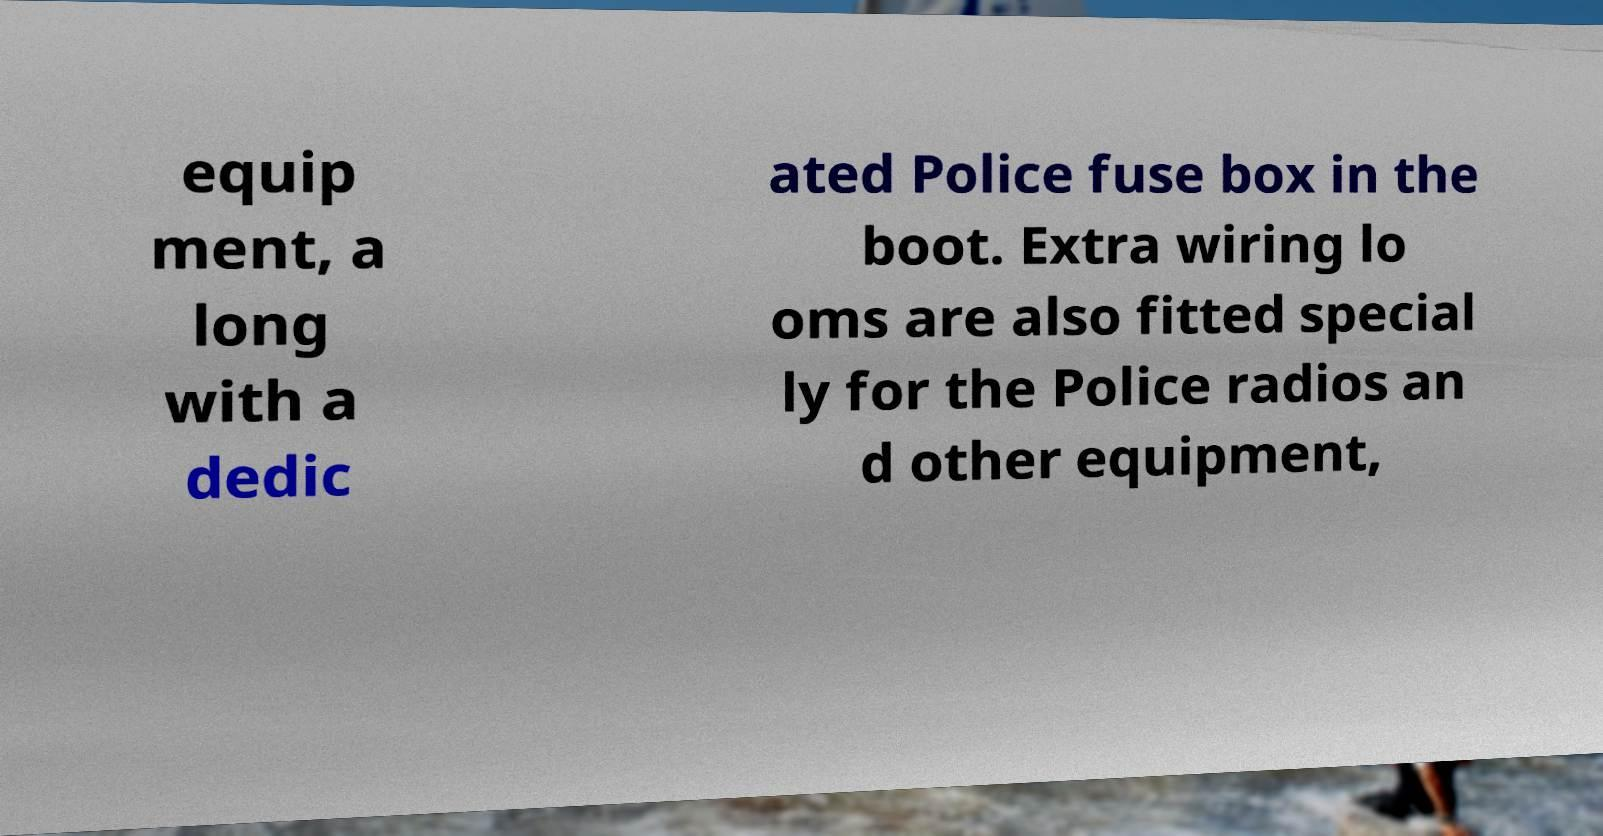For documentation purposes, I need the text within this image transcribed. Could you provide that? equip ment, a long with a dedic ated Police fuse box in the boot. Extra wiring lo oms are also fitted special ly for the Police radios an d other equipment, 